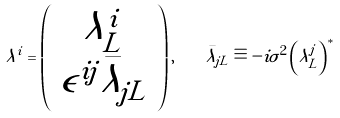<formula> <loc_0><loc_0><loc_500><loc_500>\lambda ^ { i } = \left ( \begin{array} { c } \lambda ^ { i } _ { L } \\ \epsilon ^ { i j } \bar { \lambda } _ { j L } \end{array} \right ) , \quad \bar { \lambda } _ { j L } \equiv - i \sigma ^ { 2 } \left ( \lambda ^ { j } _ { L } \right ) ^ { * }</formula> 